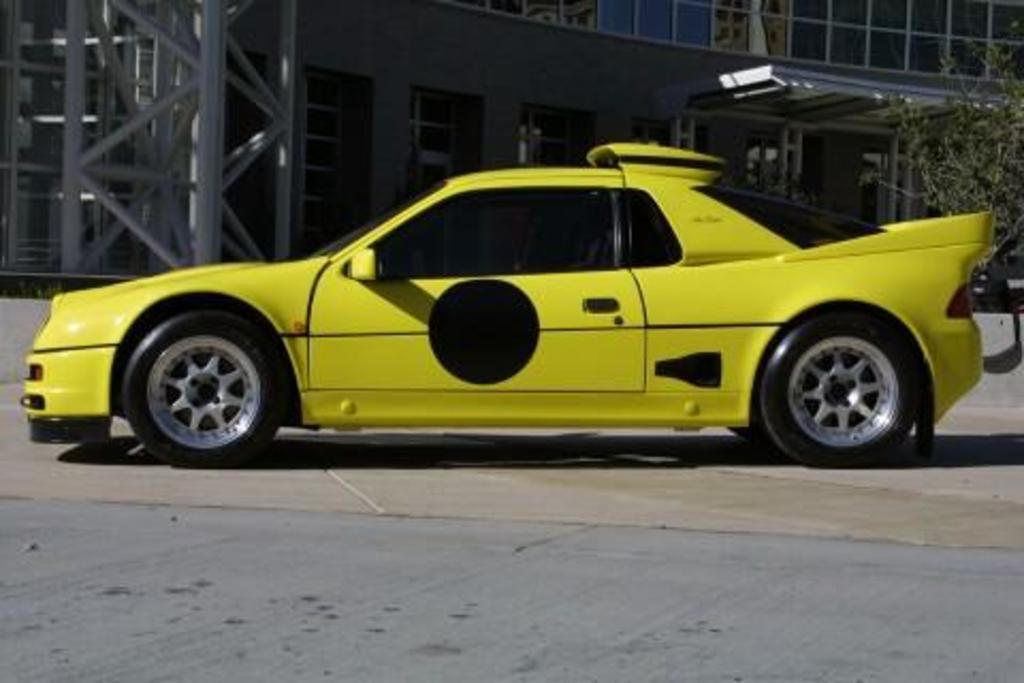What is the main subject of the image? There is a car on the road in the image. What can be seen in the background of the image? There are plants, buildings, rods, and windows in the background of the image. Can you tell me how many frogs are sitting on the furniture in the image? There are no frogs or furniture present in the image. What color is the eye of the person in the image? There is no person or eye visible in the image; it features a car on the road with a background of plants, buildings, rods, and windows. 